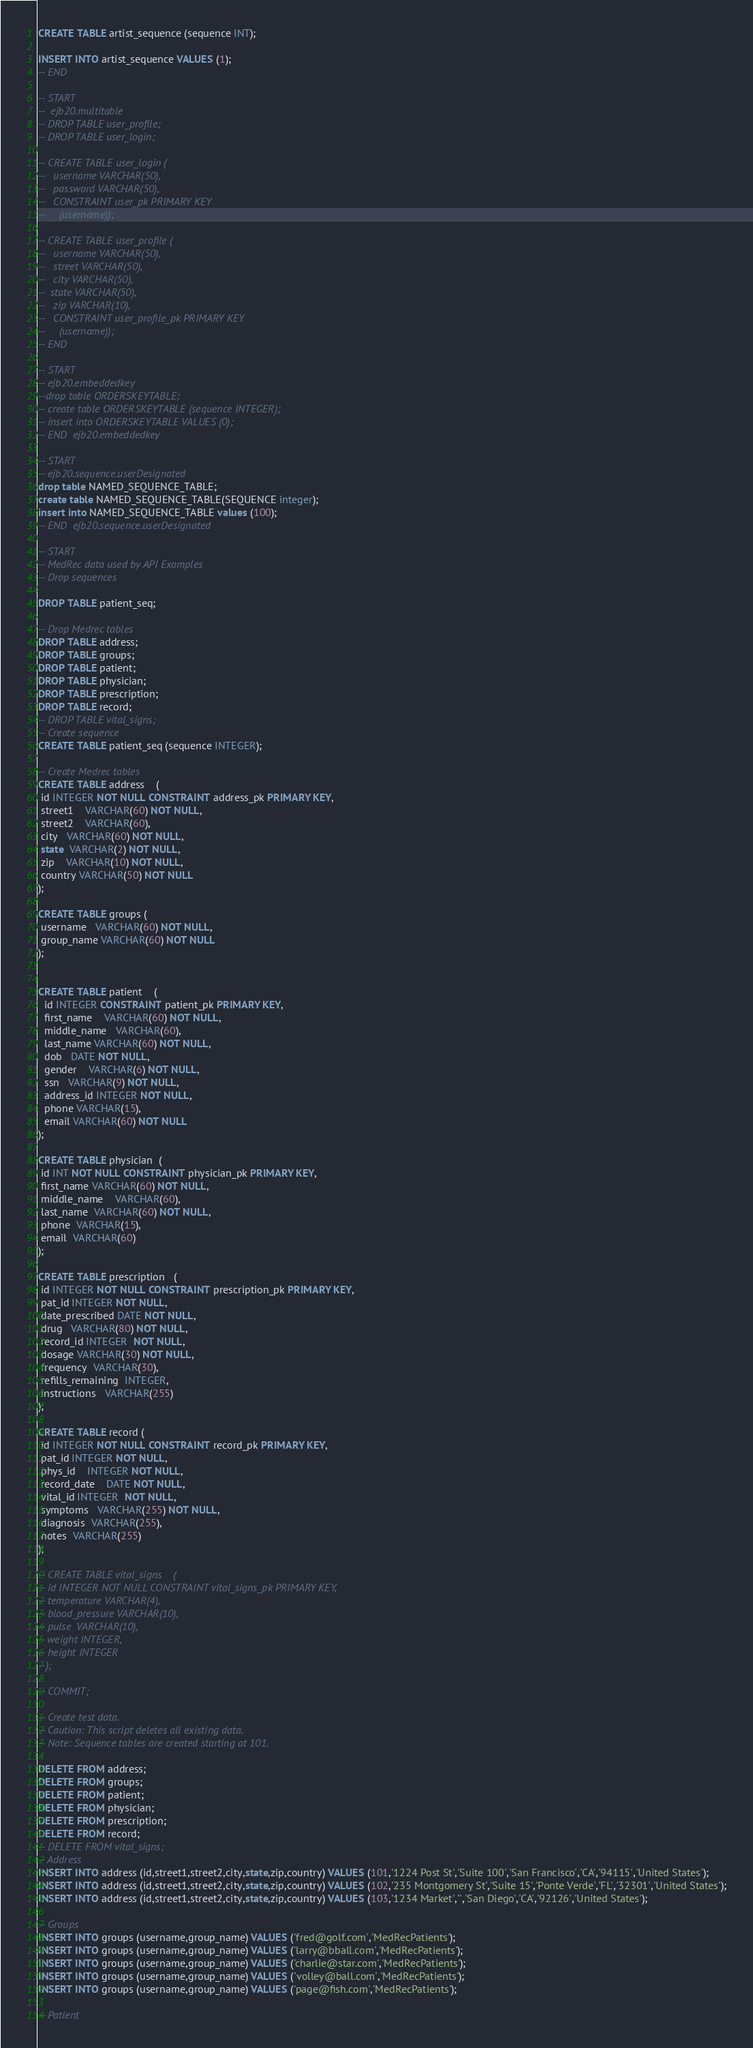Convert code to text. <code><loc_0><loc_0><loc_500><loc_500><_SQL_>
CREATE TABLE artist_sequence (sequence INT);

INSERT INTO artist_sequence VALUES (1);
-- END

-- START
--  ejb20.multitable
-- DROP TABLE user_profile;
-- DROP TABLE user_login;

-- CREATE TABLE user_login (
--   username VARCHAR(50),
--   password VARCHAR(50),
--   CONSTRAINT user_pk PRIMARY KEY
--     (username));

-- CREATE TABLE user_profile (
--   username VARCHAR(50),
--   street VARCHAR(50),
--   city VARCHAR(50),
--  state VARCHAR(50),
--   zip VARCHAR(10),
--   CONSTRAINT user_profile_pk PRIMARY KEY
--     (username));
-- END

-- START
-- ejb20.embeddedkey
--drop table ORDERSKEYTABLE;
-- create table ORDERSKEYTABLE (sequence INTEGER);
-- insert into ORDERSKEYTABLE VALUES (0);
-- END  ejb20.embeddedkey

-- START
-- ejb20.sequence.userDesignated
drop table NAMED_SEQUENCE_TABLE;
create table NAMED_SEQUENCE_TABLE(SEQUENCE integer);
insert into NAMED_SEQUENCE_TABLE values (100);
-- END  ejb20.sequence.userDesignated

-- START
-- MedRec data used by API Examples
-- Drop sequences

DROP TABLE patient_seq;

-- Drop Medrec tables
DROP TABLE address;
DROP TABLE groups;
DROP TABLE patient;
DROP TABLE physician;
DROP TABLE prescription;
DROP TABLE record;
-- DROP TABLE vital_signs;
-- Create sequence
CREATE TABLE patient_seq (sequence INTEGER);

-- Create Medrec tables
CREATE TABLE address    (
 id INTEGER NOT NULL CONSTRAINT address_pk PRIMARY KEY,
 street1    VARCHAR(60) NOT NULL,
 street2    VARCHAR(60),
 city   VARCHAR(60) NOT NULL,
 state  VARCHAR(2) NOT NULL,
 zip    VARCHAR(10) NOT NULL,
 country VARCHAR(50) NOT NULL
);

CREATE TABLE groups (
 username   VARCHAR(60) NOT NULL,
 group_name VARCHAR(60) NOT NULL
);


CREATE TABLE patient    (
  id INTEGER CONSTRAINT patient_pk PRIMARY KEY,
  first_name    VARCHAR(60) NOT NULL,
  middle_name   VARCHAR(60),
  last_name VARCHAR(60) NOT NULL,
  dob   DATE NOT NULL,
  gender    VARCHAR(6) NOT NULL,
  ssn   VARCHAR(9) NOT NULL,
  address_id INTEGER NOT NULL,
  phone VARCHAR(15),
  email VARCHAR(60) NOT NULL
);

CREATE TABLE physician  (
 id INT NOT NULL CONSTRAINT physician_pk PRIMARY KEY,
 first_name VARCHAR(60) NOT NULL,
 middle_name    VARCHAR(60),
 last_name  VARCHAR(60) NOT NULL,
 phone  VARCHAR(15),
 email  VARCHAR(60)
);

CREATE TABLE prescription   (
 id INTEGER NOT NULL CONSTRAINT prescription_pk PRIMARY KEY,
 pat_id INTEGER NOT NULL,
 date_prescribed DATE NOT NULL,
 drug   VARCHAR(80) NOT NULL,
 record_id INTEGER  NOT NULL,
 dosage VARCHAR(30) NOT NULL,
 frequency  VARCHAR(30),
 refills_remaining  INTEGER,
 instructions   VARCHAR(255)
);

CREATE TABLE record (
 id INTEGER NOT NULL CONSTRAINT record_pk PRIMARY KEY,
 pat_id INTEGER NOT NULL,
 phys_id    INTEGER NOT NULL,
 record_date    DATE NOT NULL,
 vital_id INTEGER  NOT NULL,
 symptoms   VARCHAR(255) NOT NULL,
 diagnosis  VARCHAR(255),
 notes  VARCHAR(255)
);

-- CREATE TABLE vital_signs    (
-- id INTEGER NOT NULL CONSTRAINT vital_signs_pk PRIMARY KEY,
-- temperature VARCHAR(4),
-- blood_pressure VARCHAR(10),
-- pulse  VARCHAR(10),
-- weight INTEGER,
-- height INTEGER
--);

-- COMMIT;

-- Create test data.
-- Caution: This script deletes all existing data.
-- Note: Sequence tables are created starting at 101.

DELETE FROM address;
DELETE FROM groups;
DELETE FROM patient;
DELETE FROM physician;
DELETE FROM prescription;
DELETE FROM record;
-- DELETE FROM vital_signs;
-- Address
INSERT INTO address (id,street1,street2,city,state,zip,country) VALUES (101,'1224 Post St','Suite 100','San Francisco','CA','94115','United States');
INSERT INTO address (id,street1,street2,city,state,zip,country) VALUES (102,'235 Montgomery St','Suite 15','Ponte Verde','FL','32301','United States');
INSERT INTO address (id,street1,street2,city,state,zip,country) VALUES (103,'1234 Market','','San Diego','CA','92126','United States');

-- Groups
INSERT INTO groups (username,group_name) VALUES ('fred@golf.com','MedRecPatients');
INSERT INTO groups (username,group_name) VALUES ('larry@bball.com','MedRecPatients');
INSERT INTO groups (username,group_name) VALUES ('charlie@star.com','MedRecPatients');
INSERT INTO groups (username,group_name) VALUES ('volley@ball.com','MedRecPatients');
INSERT INTO groups (username,group_name) VALUES ('page@fish.com','MedRecPatients');

-- Patient</code> 